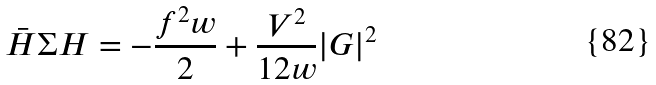Convert formula to latex. <formula><loc_0><loc_0><loc_500><loc_500>\bar { H } \Sigma H = - \frac { f ^ { 2 } w } { 2 } + \frac { V ^ { 2 } } { 1 2 w } | G | ^ { 2 }</formula> 